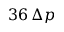<formula> <loc_0><loc_0><loc_500><loc_500>3 6 \, \Delta p</formula> 